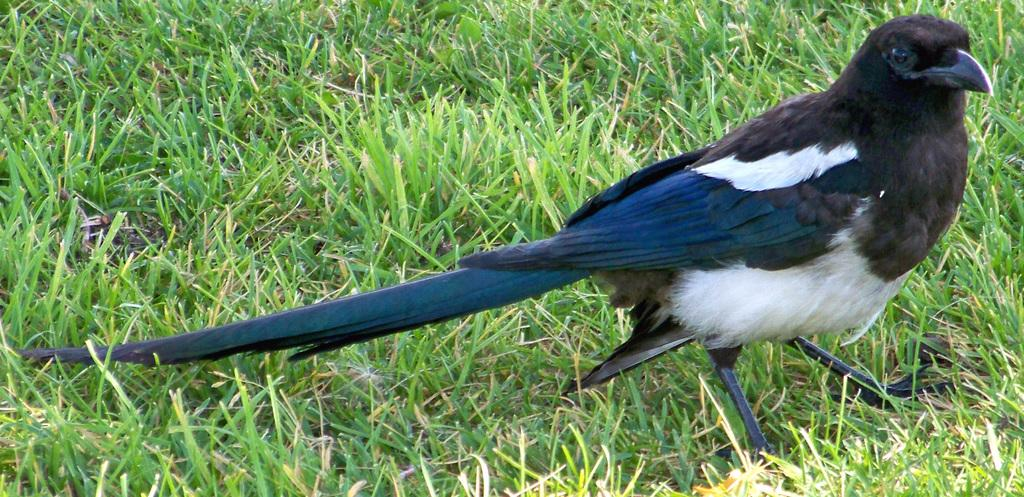What type of animal can be seen in the image? There is a bird in the image. What is the bird doing in the image? The bird is standing in the image. What type of vegetation is present in the image? There is grass in the image. What is the color of the grass in the image? The grass is green in color. Where is the hen sleeping in the image? There is no hen present in the image, only a bird. What is the quarter used for in the image? There is no quarter present in the image. 